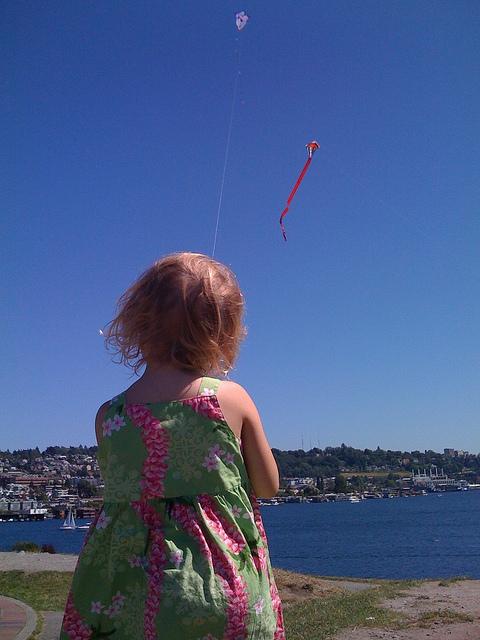What is being flown?
Give a very brief answer. Kite. Is it summer?
Write a very short answer. Yes. What type of fan is she holding?
Be succinct. Kite. What animal does the kite represent?
Be succinct. Snake. Is it an older man flying the kite?
Keep it brief. No. Is there a person in the water?
Short answer required. No. 